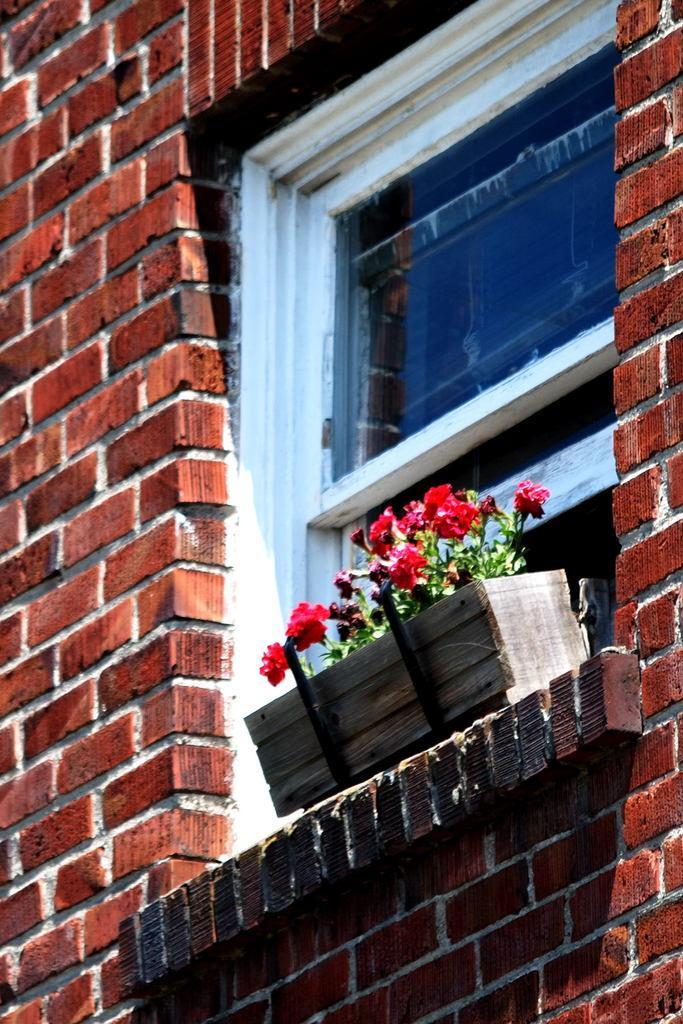Describe this image in one or two sentences. In this image I can see a window to the wall. Beside the window there is a wooden box which consists of some flower plants. 